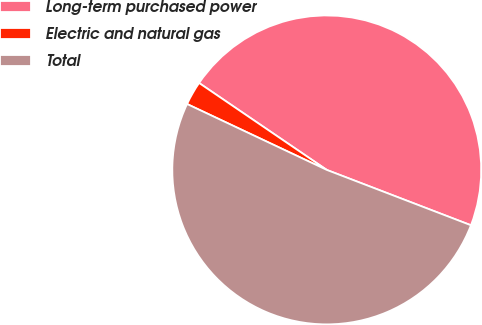<chart> <loc_0><loc_0><loc_500><loc_500><pie_chart><fcel>Long-term purchased power<fcel>Electric and natural gas<fcel>Total<nl><fcel>46.32%<fcel>2.5%<fcel>51.18%<nl></chart> 